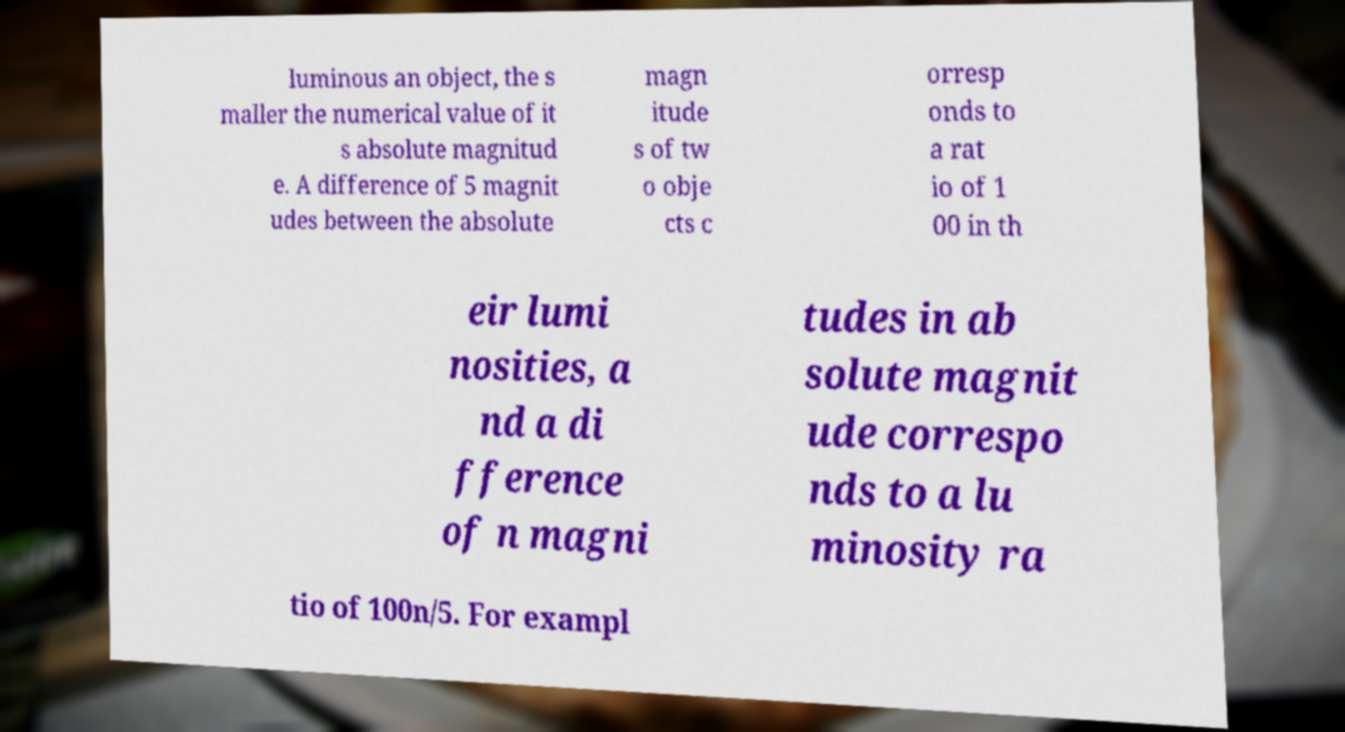Please identify and transcribe the text found in this image. luminous an object, the s maller the numerical value of it s absolute magnitud e. A difference of 5 magnit udes between the absolute magn itude s of tw o obje cts c orresp onds to a rat io of 1 00 in th eir lumi nosities, a nd a di fference of n magni tudes in ab solute magnit ude correspo nds to a lu minosity ra tio of 100n/5. For exampl 